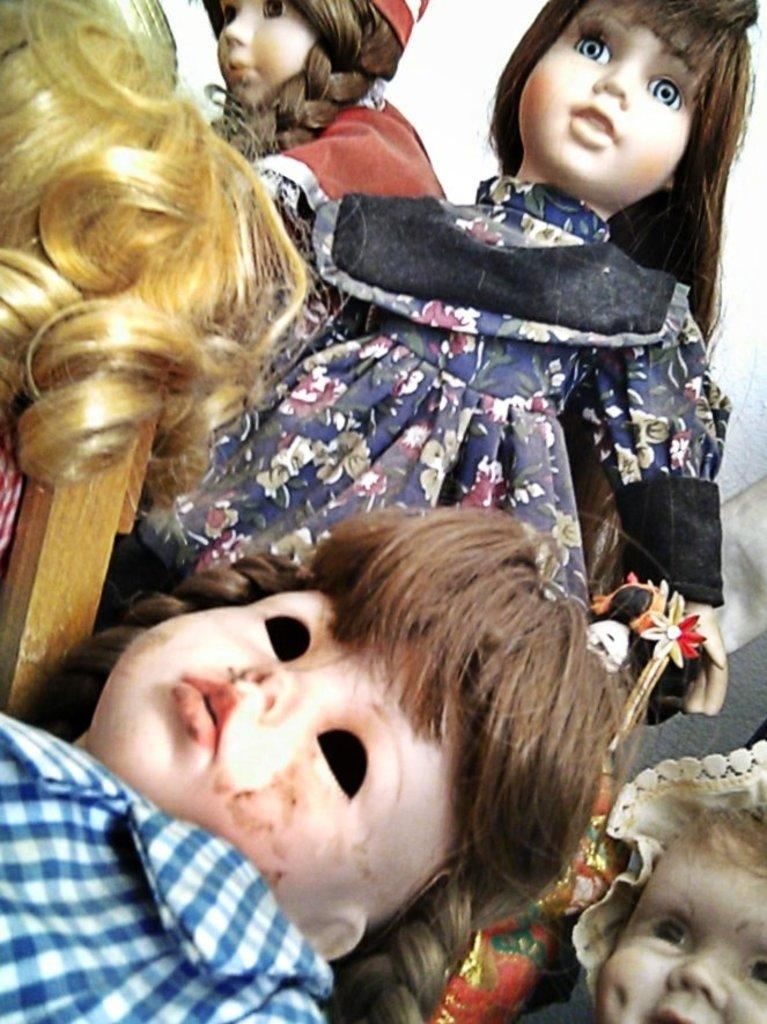How many dolls with clothes are present in the image? There are four dolls with clothes in the image. What type of element resembles hair in the image? There is a hair-like element in the image. What material is the wooden stick made of in the image? The wooden stick in the image is made of wood. What type of hat can be seen on the dolls in the image? There is no hat visible on the dolls in the image. Can you tell me how many celery stalks are present in the image? There is no celery present in the image. 